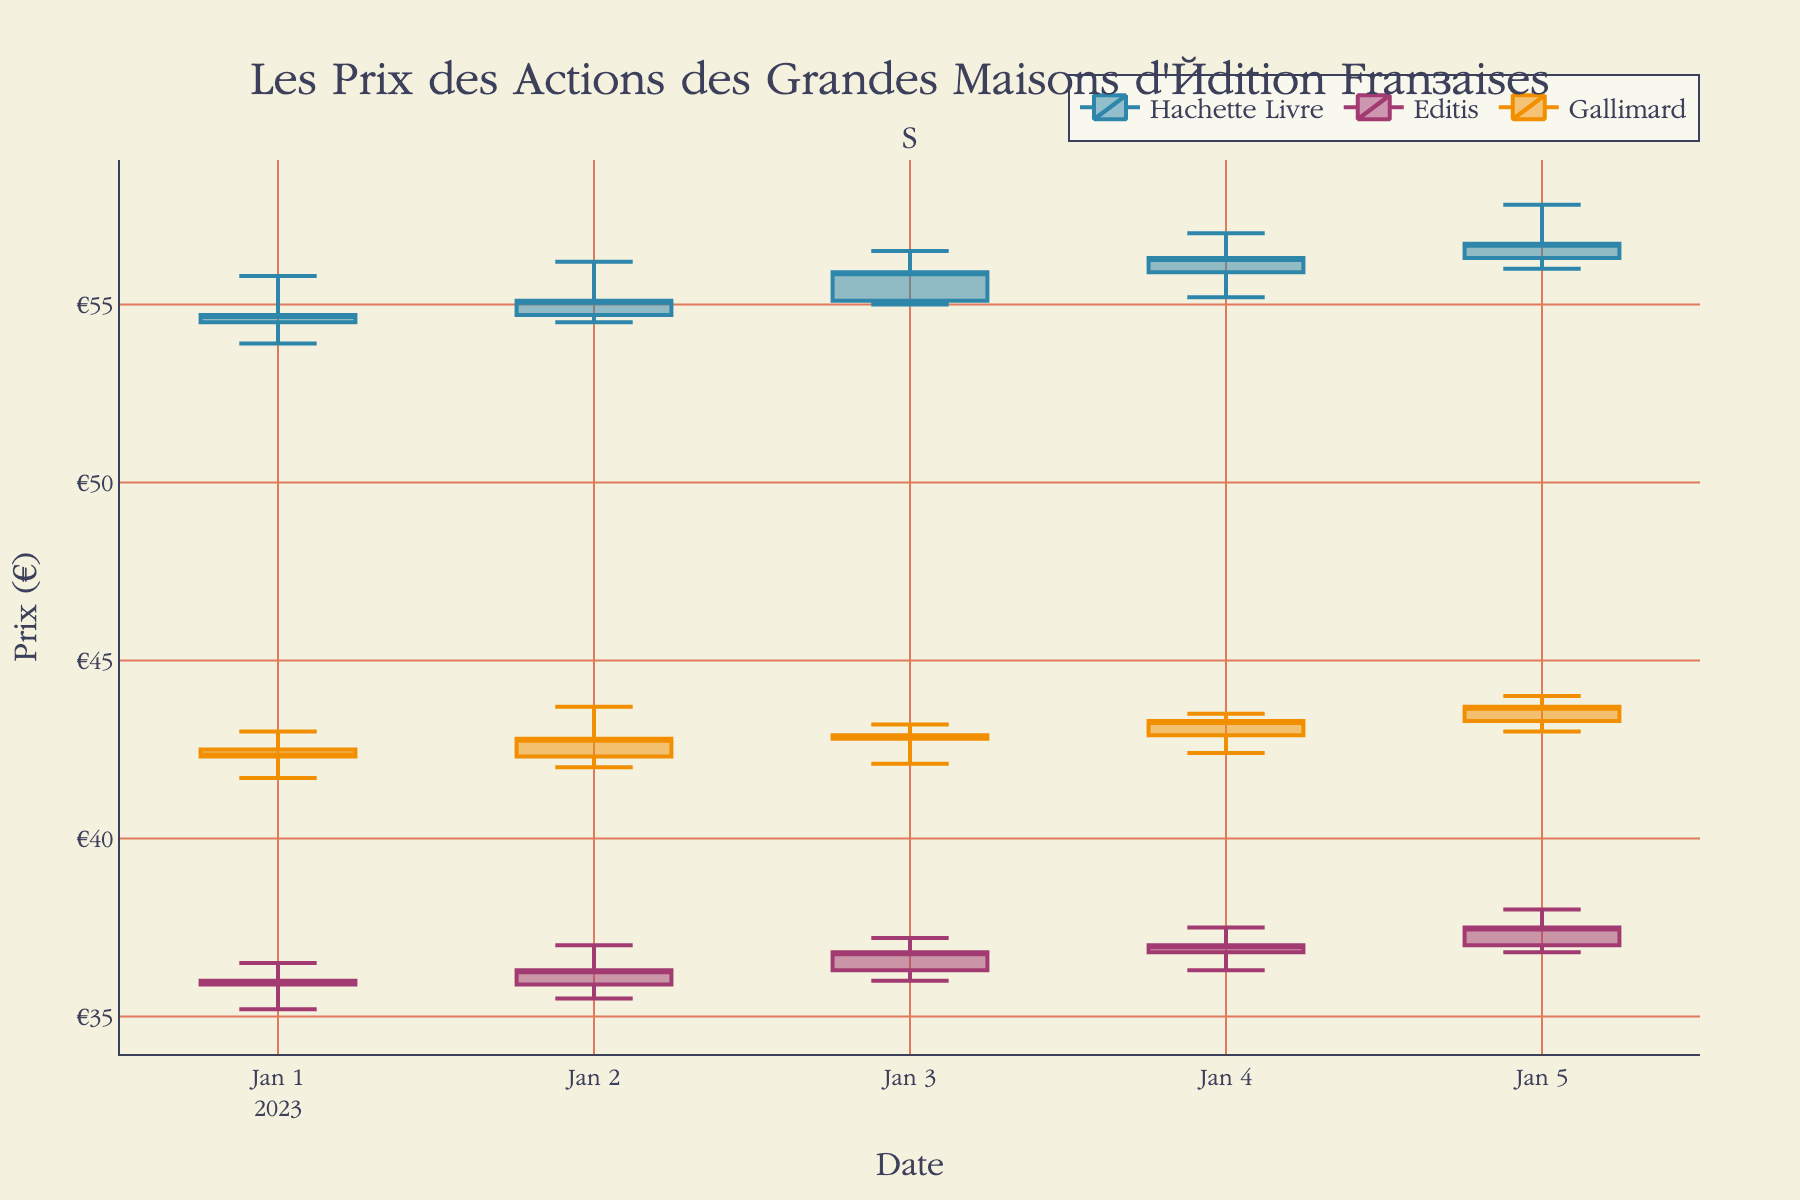what is the title of the figure? The title of the figure is located at the top of the chart. It is written in a larger font compared to other text elements on the figure.
Answer: Les Prix des Actions des Grandes Maisons d'Édition Françaises how many companies are tracked in the plot? The plot includes data for three different companies, which can be identified by the three distinct color-coded lines or bars in the figure.
Answer: Three which company had the highest stock price on January 5, 2023? By looking at the highest points (High) of the candlestick on January 5 for each company, Gallimard has the highest price of 44.0.
Answer: Gallimard what was the closing price for Editis on January 3, 2023? By locating the candlestick for Editis on January 3, 2023, the closing price is represented by the point corresponding to the Close value. It is 36.8.
Answer: 36.8 which company showed the largest increase between the opening price on January 1, 2023, and the closing price on January 5, 2023? Calculate the difference between the closing price on January 5 and the opening price on January 1 for each company: Hachette Livre (56.7 - 54.5 = 2.2), Editis (37.5 - 36.0 = 1.5), Gallimard (43.7 - 42.5 = 1.2). Hachette Livre had the largest increase of 2.2.
Answer: Hachette Livre which company had the lowest volume on January 4, 2023? By checking the volume values for each company on January 4, 2023, Gallimard had the lowest volume of 10,200. The lower part of the candlestick also sometimes visually indicates this, but the exact number is clearer.
Answer: Gallimard did Gallimard’s stock price close higher on January 1, 2023, or January 5, 2023? Examining the candlesticks for Gallimard on both dates, the closing price on January 1 is 42.3 and on January 5 is 43.7. The closing price is higher on January 5.
Answer: January 5, 2023 how does the color help in differentiating the companies? The color distinguishes each company by implementing a different color for each company’s candlesticks: Hachette Livre in blue, Editis in purple, and Gallimard in orange.
Answer: Different colors what pattern can be observed in the stock prices of Editis from January 1 to January 5, 2023? Observing the candlesticks for Editis over the given dates, the stock price shows a gradual increase from 35.9 on January 1 to 37.5 on January 5. This indicates a consistent upward trend throughout the period.
Answer: Upward trend which company experienced the most volatility between January 1 and January 5, 2023? Volatility can be inferred by looking at the range between the High and Low values for each company across the period. Hachette Livre had the largest range in its candlestick heights, suggesting more volatility in its stock prices.
Answer: Hachette Livre 